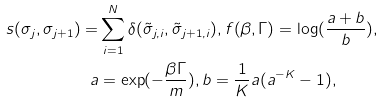<formula> <loc_0><loc_0><loc_500><loc_500>s ( \sigma _ { j } , \sigma _ { j + 1 } ) = & \sum _ { i = 1 } ^ { N } \delta ( { \tilde { \sigma } } _ { j , i } , { \tilde { \sigma } } _ { j + 1 , i } ) , f ( \beta , \Gamma ) = \log ( \frac { a + b } { b } ) , \\ a & = \exp ( { - \frac { \beta \Gamma } { m } } ) , b = \frac { 1 } { K } a ( a ^ { - K } - 1 ) ,</formula> 